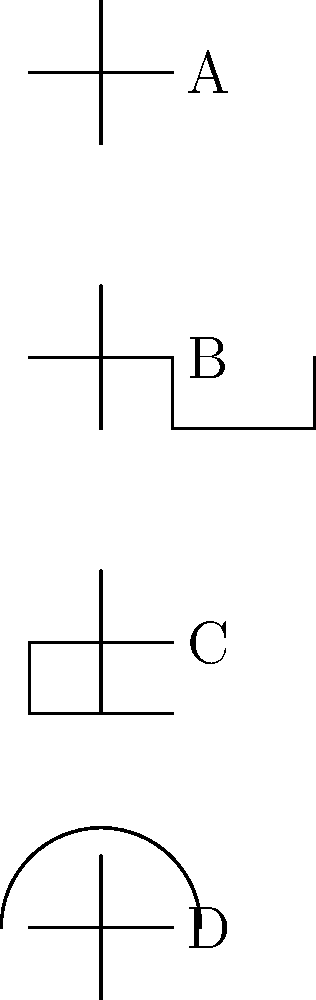As a seasoned comic illustrator with an eye for detail, you've been tasked with identifying different types of capacitors in a circuit diagram. Based on the schematic symbols shown above, which one represents a polarized electrolytic capacitor? To identify the polarized electrolytic capacitor, let's analyze each symbol step-by-step:

1. Symbol A: This is a standard capacitor symbol with two parallel lines. It represents a non-polarized capacitor, typically used for ceramic or film capacitors.

2. Symbol B: This symbol shows a capacitor with one curved line, which indicates a variable capacitor. These are used in applications where capacitance needs to be adjustable.

3. Symbol C: This symbol has one straight line and one curved line with a plus sign. The curved line represents the cathode, and the plus sign indicates the anode. This is the symbol for a polarized electrolytic capacitor.

4. Symbol D: This symbol shows a capacitor with a curved line above it, which represents a feedthrough capacitor. These are used for filtering high-frequency noise in power supply lines.

As an illustrator, you'd recognize that the added details in symbol C (the curved line and plus sign) are intentional and signify specific properties of the component, much like how inking techniques can convey texture and depth in comics.
Answer: C 